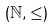<formula> <loc_0><loc_0><loc_500><loc_500>( \mathbb { N } , \leq )</formula> 